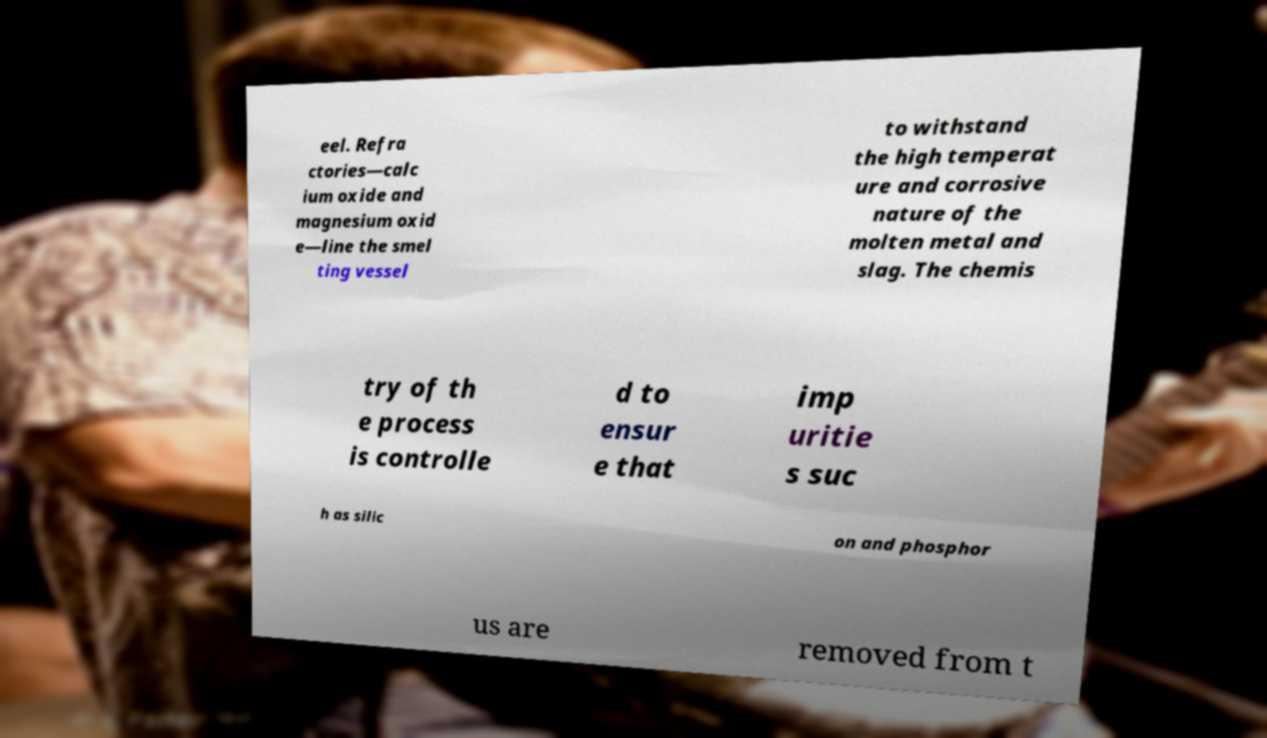Can you read and provide the text displayed in the image?This photo seems to have some interesting text. Can you extract and type it out for me? eel. Refra ctories—calc ium oxide and magnesium oxid e—line the smel ting vessel to withstand the high temperat ure and corrosive nature of the molten metal and slag. The chemis try of th e process is controlle d to ensur e that imp uritie s suc h as silic on and phosphor us are removed from t 